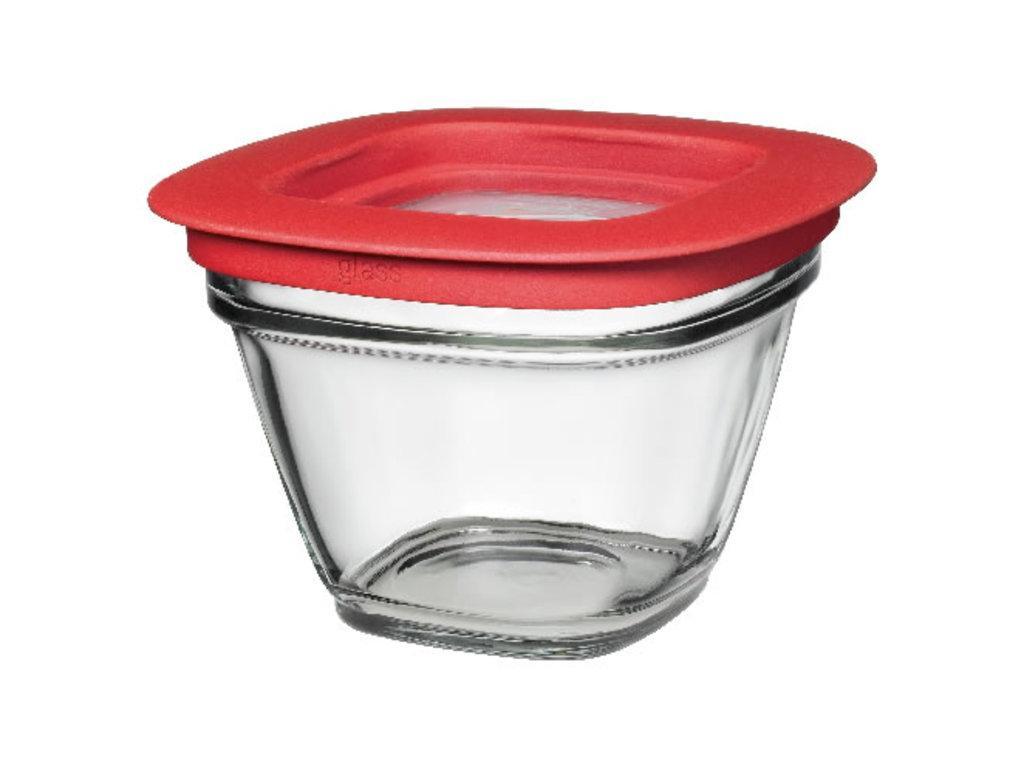How would you summarize this image in a sentence or two? Here we can see a glass bowl with red lid. Background it is in white color. 